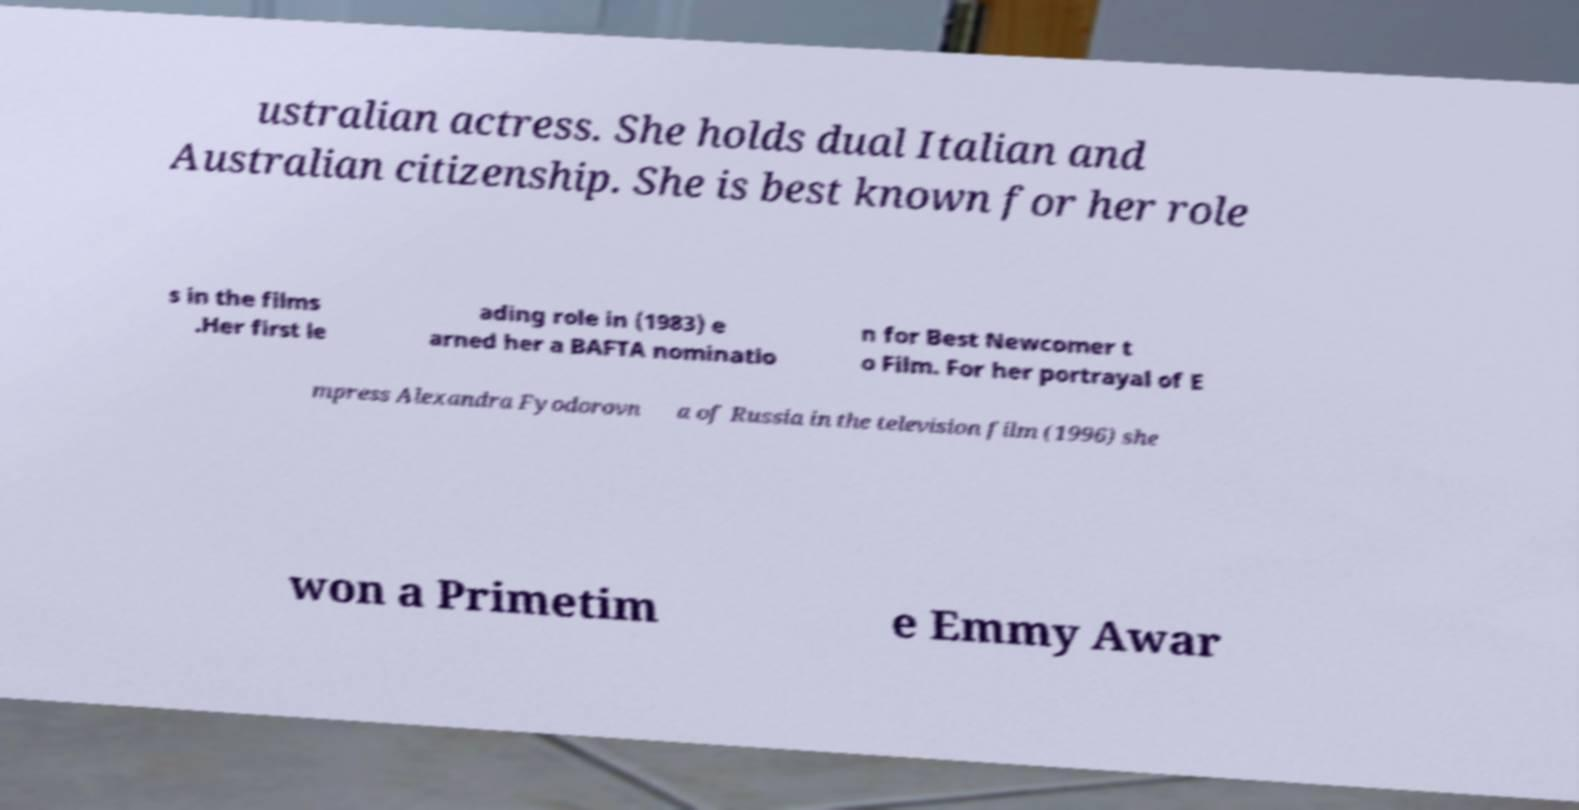What messages or text are displayed in this image? I need them in a readable, typed format. ustralian actress. She holds dual Italian and Australian citizenship. She is best known for her role s in the films .Her first le ading role in (1983) e arned her a BAFTA nominatio n for Best Newcomer t o Film. For her portrayal of E mpress Alexandra Fyodorovn a of Russia in the television film (1996) she won a Primetim e Emmy Awar 